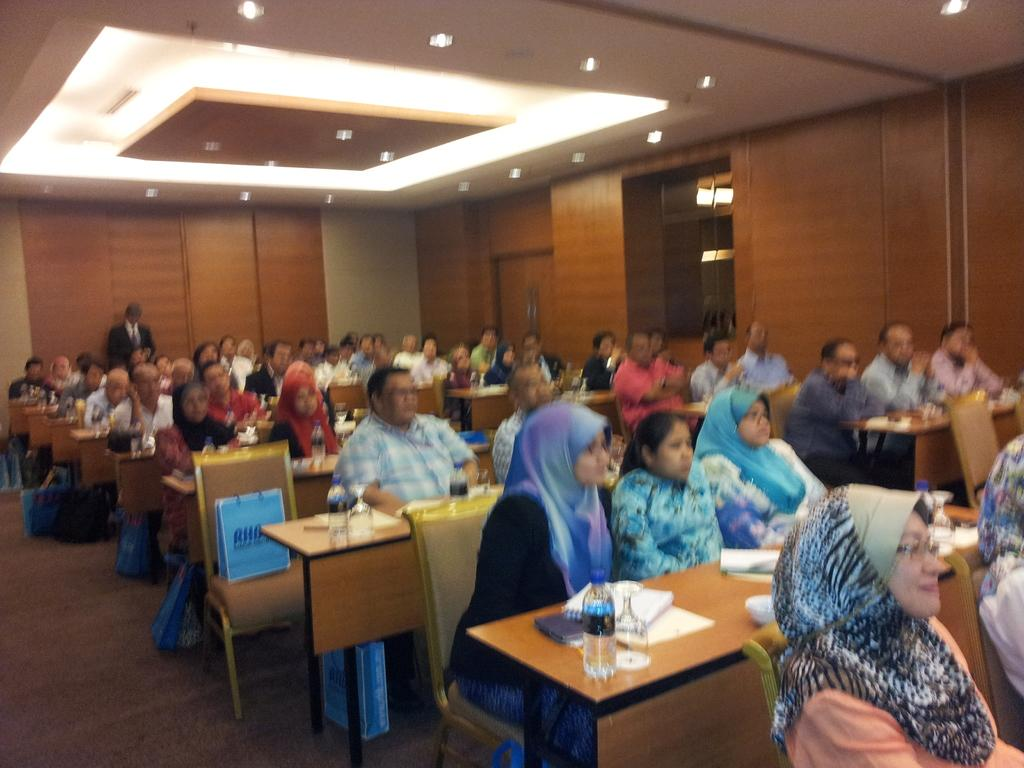What are the people in the image doing? The people in the image are sitting on benches. What is located in front of the benches? There is a table in front of the benches. What can be seen on the table? There is a wine glass, a water bottle, books, and paper on the table. What type of crib is visible in the image? There is no crib present in the image. What decisions is the committee making in the image? There is no committee present in the image, and therefore no decisions are being made. 